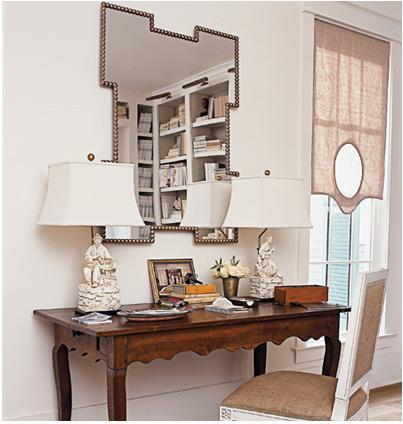What is the color and style of the lampshade on the table lamp? The lampshade is white and sculpture base designed. For a product advertisement, describe the mirror on the wall. Introducing our large geometric mirror with brass dots, perfect for brightening up your white-painted room while reflecting your sophisticated taste in home décor. What can be seen in the reflection of the mirror? A bookcase with white shelves. Describe where the white flowers are placed in the image. The white flowers are placed in a brass vase on a brown wooden table. Which object in the image has an antique blue and gold appearance? A dish placed on the brown wooden table. In the context of referential expression grounding, describe the size and shape of the mirror in the image. The mirror is large, with a geometric shape and brass dots. What's the color of the wall in the image? The wall is painted white. Identify the type of chair in the image. A white chair with burlap seats. What is unique about the curtains on the door? The curtains are tan with a circle cut-out design. For a visual entailment task, confirm or deny: There is a stack of books on the desk. Confirm 